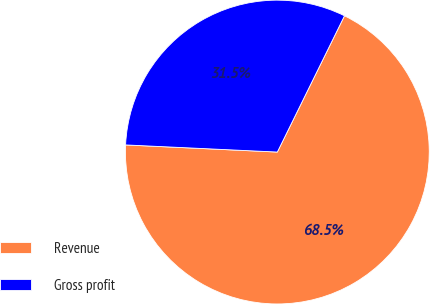Convert chart to OTSL. <chart><loc_0><loc_0><loc_500><loc_500><pie_chart><fcel>Revenue<fcel>Gross profit<nl><fcel>68.46%<fcel>31.54%<nl></chart> 